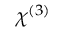<formula> <loc_0><loc_0><loc_500><loc_500>\chi ^ { ( 3 ) }</formula> 